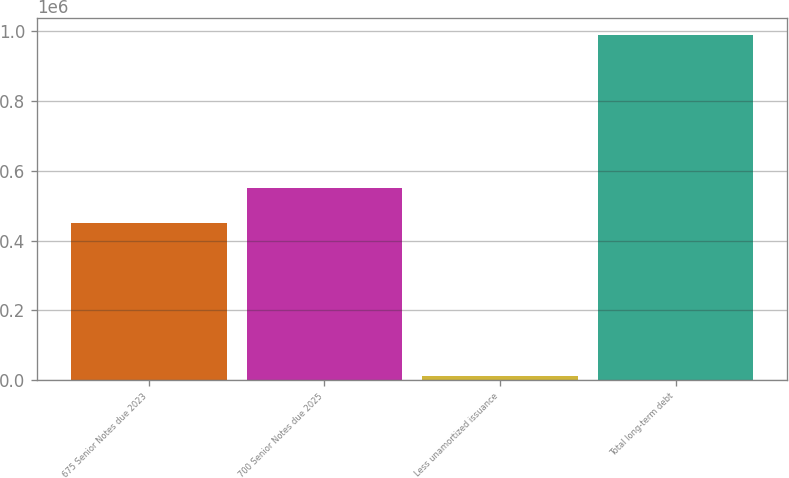Convert chart. <chart><loc_0><loc_0><loc_500><loc_500><bar_chart><fcel>675 Senior Notes due 2023<fcel>700 Senior Notes due 2025<fcel>Less unamortized issuance<fcel>Total long-term debt<nl><fcel>450000<fcel>550000<fcel>10846<fcel>989154<nl></chart> 